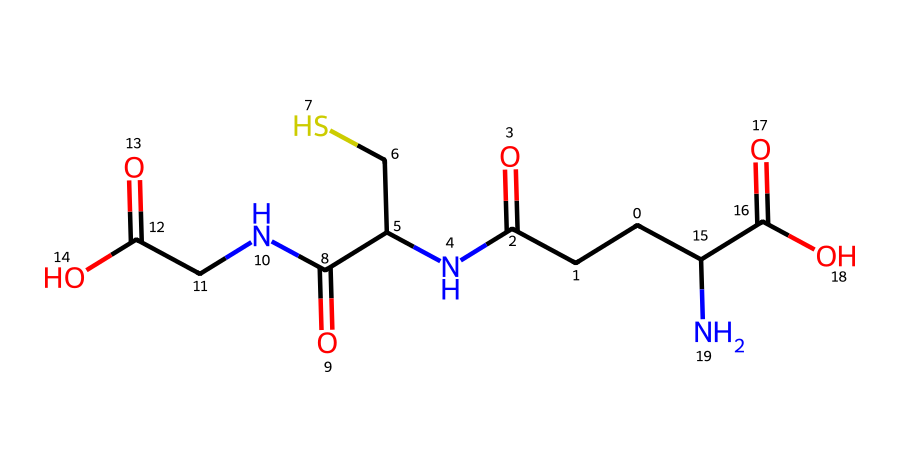What is the molecular formula of glutathione in this representation? To determine the molecular formula, one must count the number of each type of atom in the SMILES representation. From the SMILES, we can identify the presence of carbon (C), nitrogen (N), oxygen (O), and sulfur (S) atoms. There are 10 carbon atoms, 2 nitrogen atoms, 5 oxygen atoms, and 1 sulfur atom. Thus, the molecular formula combines these counts to C10H17N3O5S.
Answer: C10H17N3O5S How many nitrogen atoms are present in this chemical structure? By examining the SMILES notation, we can count the 'N' symbols, which represent nitrogen atoms. There are 2 'N' symbols, indicating that there are 2 nitrogen atoms in glutathione.
Answer: 2 What type of functional groups are present in glutathione? A review of the structure reveals the presence of amine groups (due to nitrogen atoms connected to carbon), carboxylic acid groups (indicated by the presence of -COOH), and a thiol group (associated with the sulfur atom). These functional groups contribute to its antioxidant activity.
Answer: amine, carboxylic acid, thiol What role does the sulfur atom play in glutathione's function as an antioxidant? The sulfur atom in glutathione is part of a thiol functional group, which is crucial for its reducing capabilities. This sulfur atom can donate electrons to reactive species, effectively neutralizing them and preventing cellular damage. Thus, the presence of the thiol group is fundamental to its antioxidant role.
Answer: electron donor How does glutathione contribute to cellular detoxification processes? Glutathione acts by conjugating with harmful substances, making them more water-soluble and easier for the body to eliminate. This detoxification process is mediated through the thiol group's ability to react with various electrophiles, assisting in the clearance of reactive oxygen species and other toxic compounds from the cell.
Answer: conjugation with harmful substances What is the structural feature of glutathione that allows it to exhibit antioxidant properties? The thiol (-SH) group is the key structural feature that provides glutathione with its antioxidant ability. This group can easily donate electrons to reactive oxygen species, effectively neutralizing them and protecting cells from oxidative damage.
Answer: thiol group 